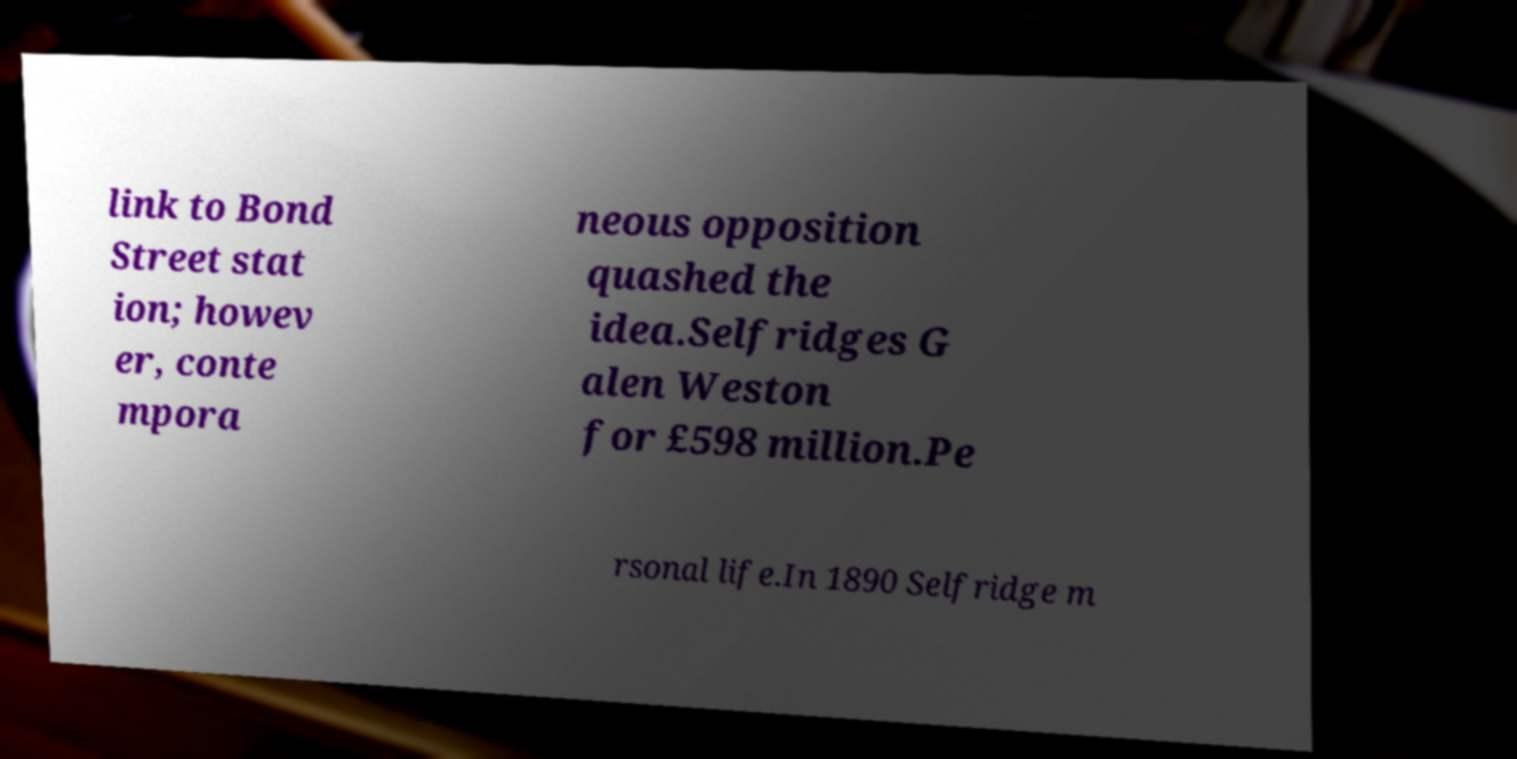Can you read and provide the text displayed in the image?This photo seems to have some interesting text. Can you extract and type it out for me? link to Bond Street stat ion; howev er, conte mpora neous opposition quashed the idea.Selfridges G alen Weston for £598 million.Pe rsonal life.In 1890 Selfridge m 